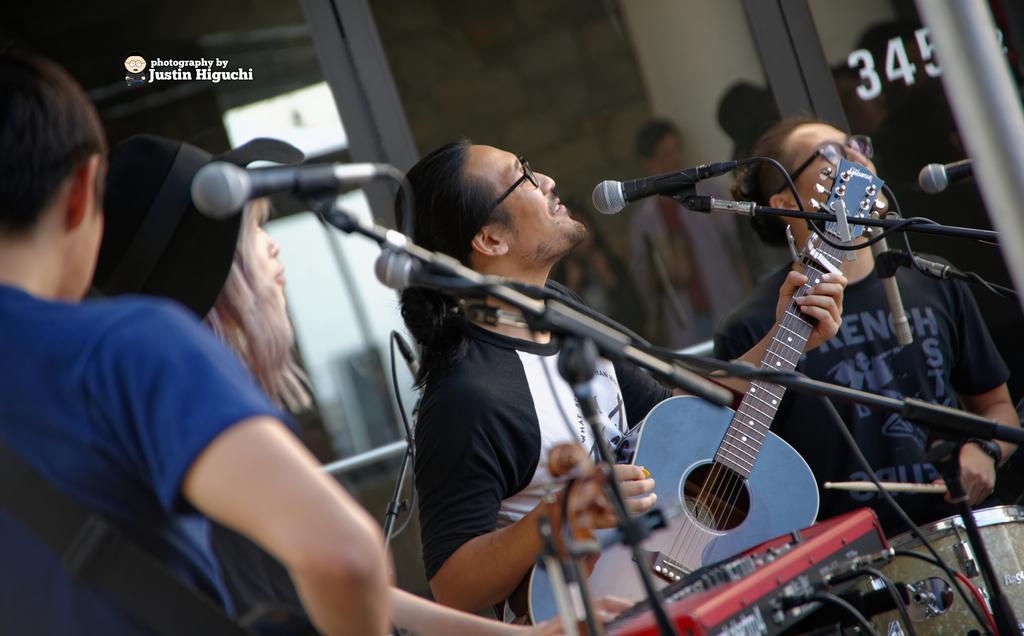Describe this image in one or two sentences. This 4 persons are highlighted in this picture. This 4 persons are playing musical instruments. This is a mic with mic holder. For the persons are standing. 